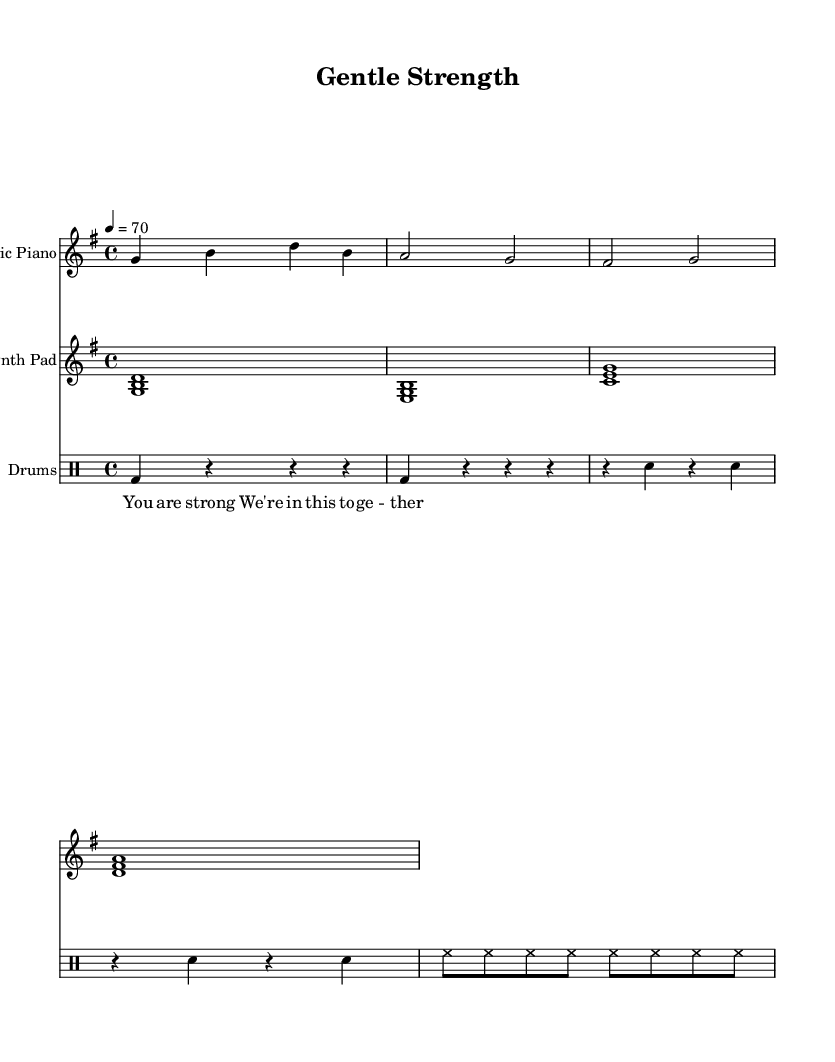What is the key signature of this music? The key signature is G major, which has one sharp (F#).
Answer: G major What is the time signature of this music? The time signature is 4/4, indicating four beats in each measure.
Answer: 4/4 What is the tempo marking for this piece? The tempo marking indicates that the piece should be played at 70 beats per minute.
Answer: 70 How many measures are there in the electric piano part? The electric piano part consists of four measures as indicated by the grouping of notes and rests.
Answer: 4 What type of instrument is used for the second staff? The second staff is labeled as a "Synth Pad," indicating it is a synthesized sound often used in electronic music.
Answer: Synth Pad What percussion instruments are indicated in the drums part? The drums part includes bass drum (bd) and snare drum (sn) as well as hi-hat (hh), which are common components of drum kits in electronic music.
Answer: Bass drum, snare drum, hi-hat 